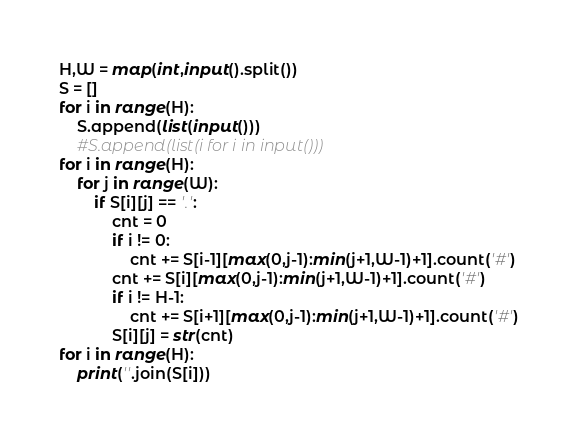Convert code to text. <code><loc_0><loc_0><loc_500><loc_500><_Python_>H,W = map(int,input().split())
S = []
for i in range(H):
    S.append(list(input()))
    #S.append(list(i for i in input()))
for i in range(H):
    for j in range(W):
        if S[i][j] == '.':
            cnt = 0
            if i != 0:
                cnt += S[i-1][max(0,j-1):min(j+1,W-1)+1].count('#')
            cnt += S[i][max(0,j-1):min(j+1,W-1)+1].count('#')
            if i != H-1:
                cnt += S[i+1][max(0,j-1):min(j+1,W-1)+1].count('#')
            S[i][j] = str(cnt)
for i in range(H):
    print(''.join(S[i]))</code> 